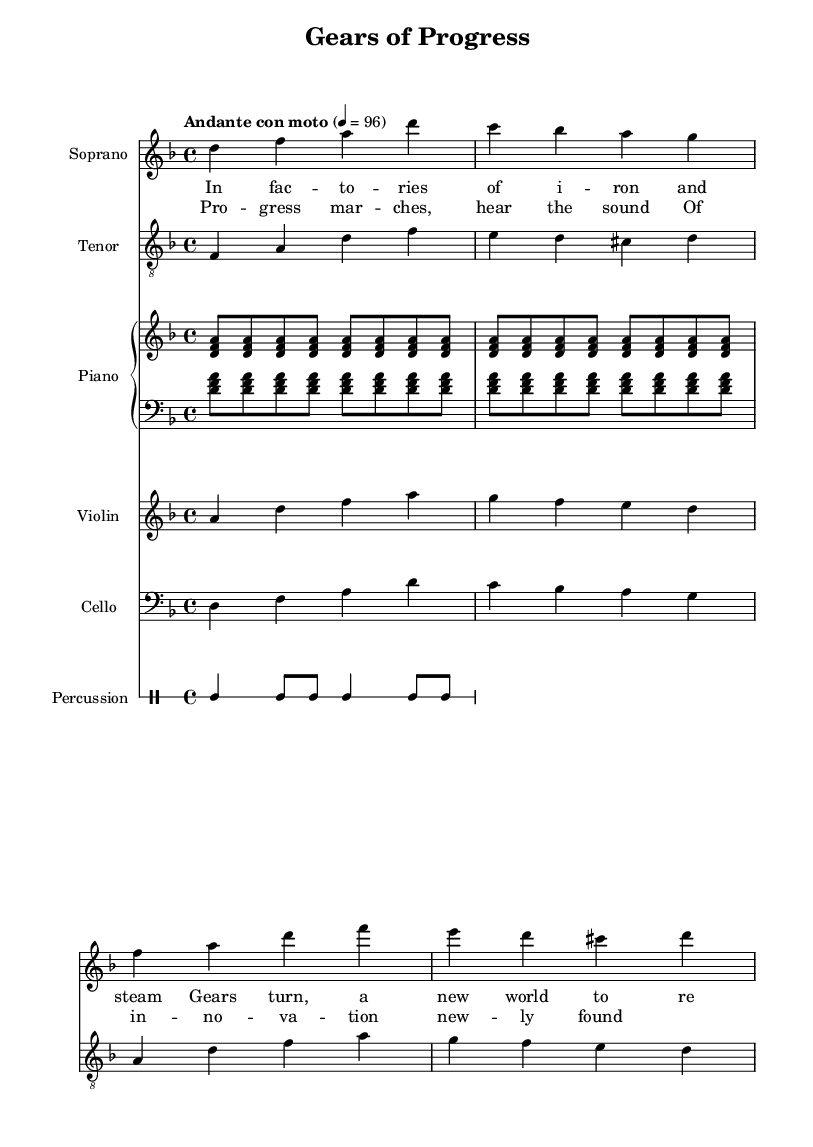What is the key signature of this music? The key signature is indicated at the beginning of the staff, and it shows two flats, which corresponds to D minor.
Answer: D minor What is the time signature of this piece? The time signature is displayed at the beginning of the music, indicating that there are four beats per measure.
Answer: 4/4 What is the tempo marking for this piece? The tempo marking is explicitly mentioned in the score, stating "Andante con moto," which indicates a moderately slow tempo with some motion.
Answer: Andante con moto How many staves are there in the score? By counting the individual staves represented in the score section, we identify a total of six staves for different instruments.
Answer: Six Which instrument plays the highest pitch in the score? Comparing the ranges of the instruments, the soprano voice generally sings higher than the other parts presented, making it the highest pitch in the score.
Answer: Soprano What is the first word of the lyrics in the verse? The lyrics are visible under the stanza marked with the verse label, and the first word in the lyrics is "In."
Answer: In What thematic element does this opera explore? Looking at the title and lyrics, the thematic element pertains to the industrial revolution, specifically focusing on engineering marvels and progress.
Answer: Industrial revolution 